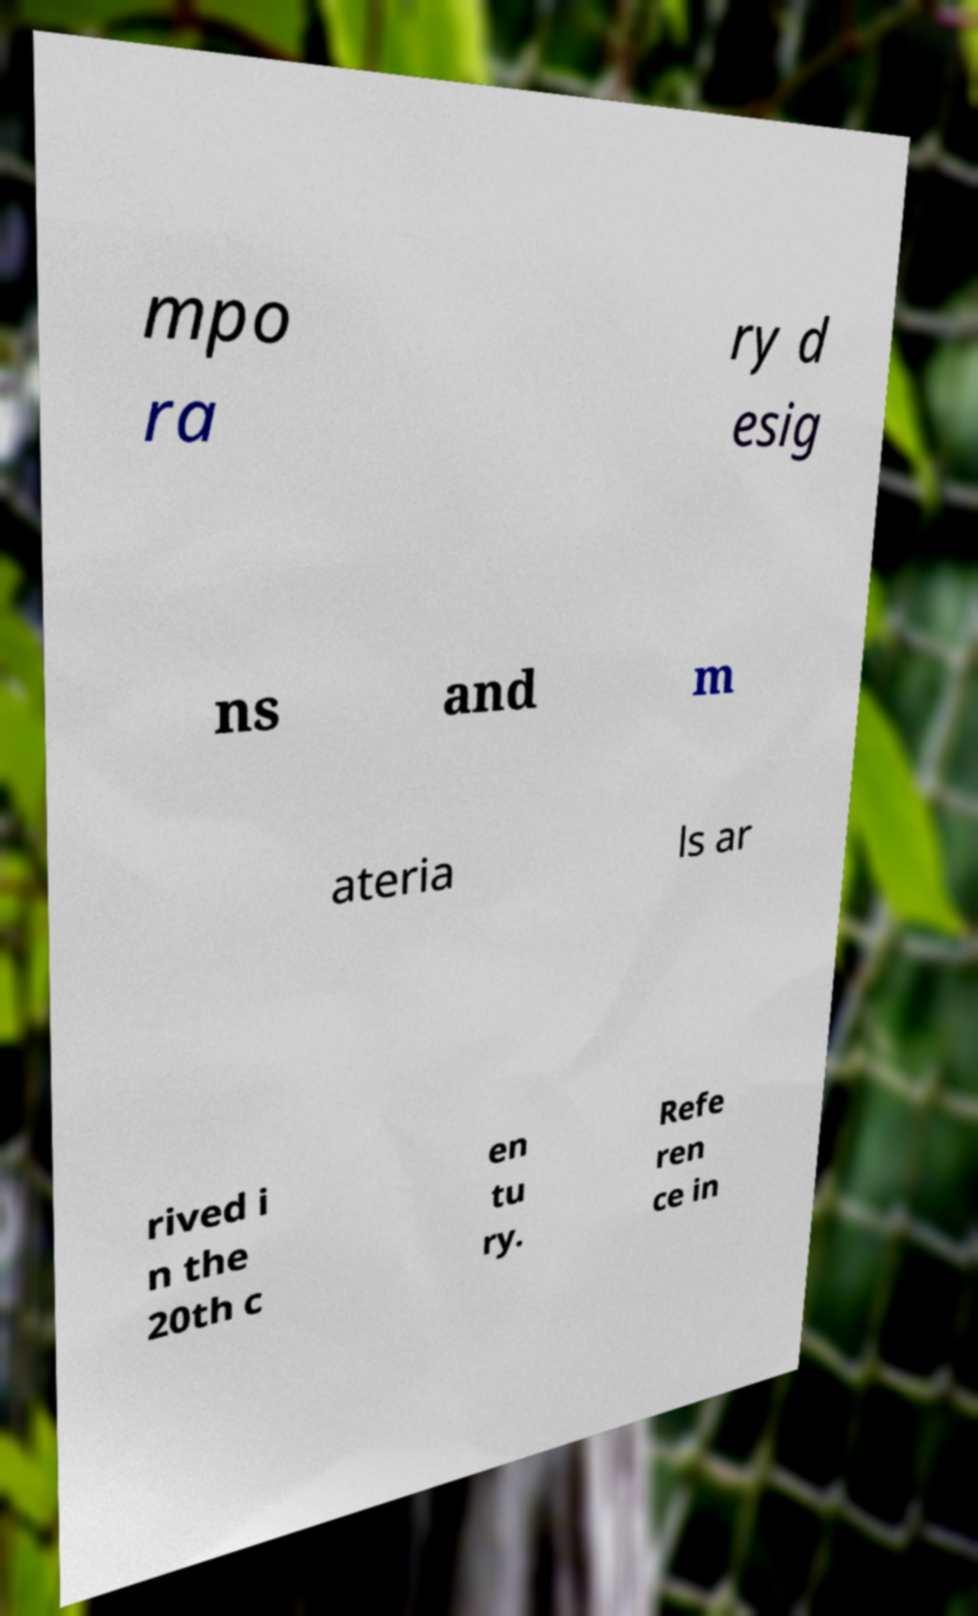Please read and relay the text visible in this image. What does it say? mpo ra ry d esig ns and m ateria ls ar rived i n the 20th c en tu ry. Refe ren ce in 